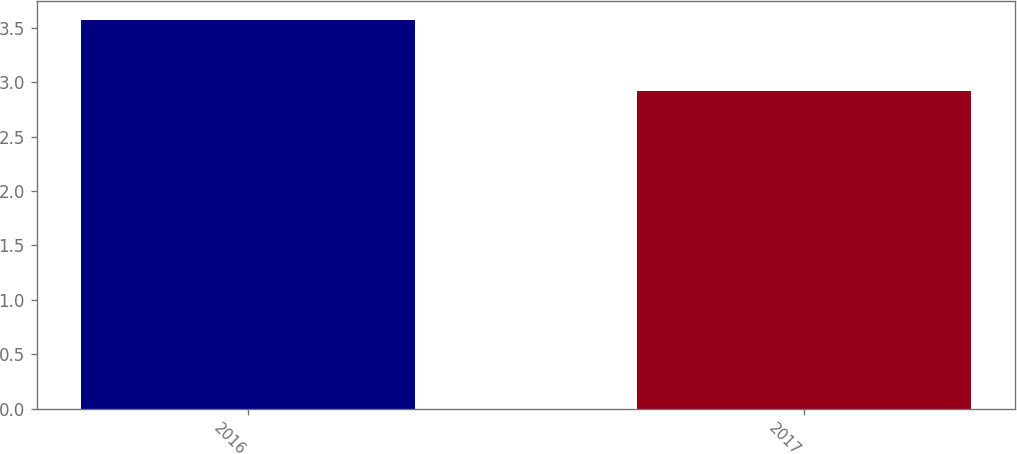Convert chart. <chart><loc_0><loc_0><loc_500><loc_500><bar_chart><fcel>2016<fcel>2017<nl><fcel>3.57<fcel>2.92<nl></chart> 